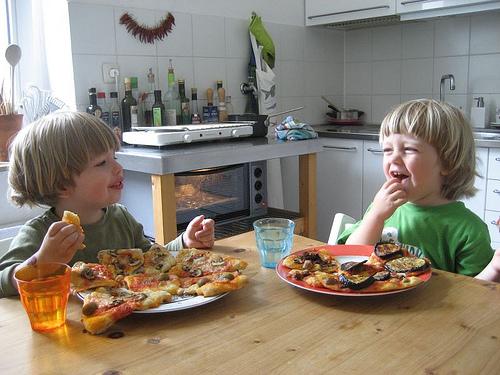What is strung on the wall?
Concise answer only. Peppers. What color is the cup on the left side of the table?
Concise answer only. Orange. How many slices of pizza are on the plates?
Quick response, please. 9. 